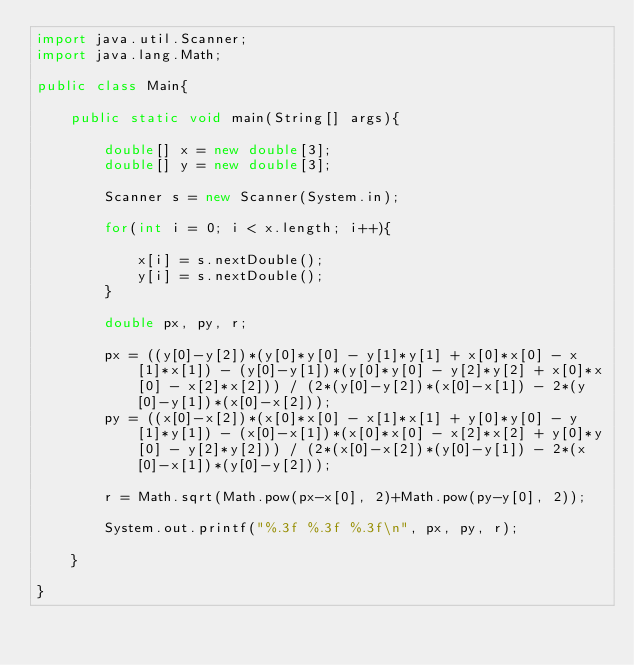Convert code to text. <code><loc_0><loc_0><loc_500><loc_500><_Java_>import java.util.Scanner;
import java.lang.Math;

public class Main{
	
	public static void main(String[] args){
		
		double[] x = new double[3];
		double[] y = new double[3];
		
		Scanner s = new Scanner(System.in);
		
		for(int i = 0; i < x.length; i++){
			
			x[i] = s.nextDouble();
			y[i] = s.nextDouble();
		}
		
		double px, py, r;
		
		px = ((y[0]-y[2])*(y[0]*y[0] - y[1]*y[1] + x[0]*x[0] - x[1]*x[1]) - (y[0]-y[1])*(y[0]*y[0] - y[2]*y[2] + x[0]*x[0] - x[2]*x[2])) / (2*(y[0]-y[2])*(x[0]-x[1]) - 2*(y[0]-y[1])*(x[0]-x[2]));
		py = ((x[0]-x[2])*(x[0]*x[0] - x[1]*x[1] + y[0]*y[0] - y[1]*y[1]) - (x[0]-x[1])*(x[0]*x[0] - x[2]*x[2] + y[0]*y[0] - y[2]*y[2])) / (2*(x[0]-x[2])*(y[0]-y[1]) - 2*(x[0]-x[1])*(y[0]-y[2]));

		r = Math.sqrt(Math.pow(px-x[0], 2)+Math.pow(py-y[0], 2));
		
		System.out.printf("%.3f %.3f %.3f\n", px, py, r);
		
	}
	
}
</code> 